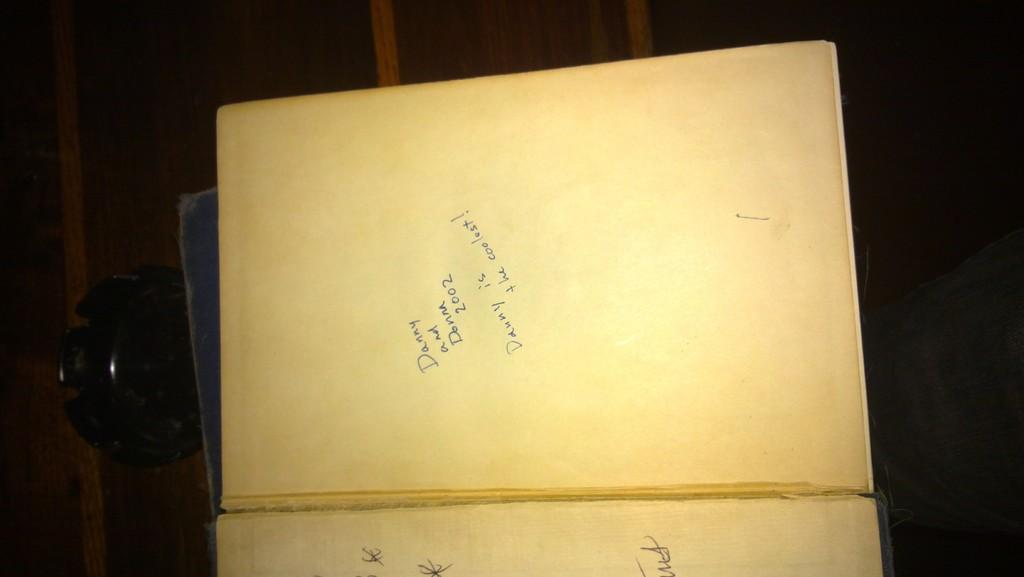Provide a one-sentence caption for the provided image. A book was given to Danny and Donna in 2002. 